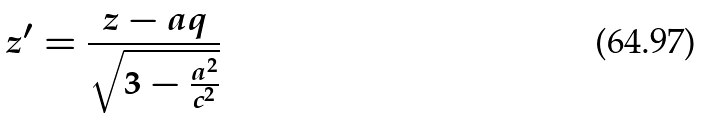<formula> <loc_0><loc_0><loc_500><loc_500>z ^ { \prime } = \frac { z - a q } { \sqrt { 3 - \frac { a ^ { 2 } } { c ^ { 2 } } } }</formula> 